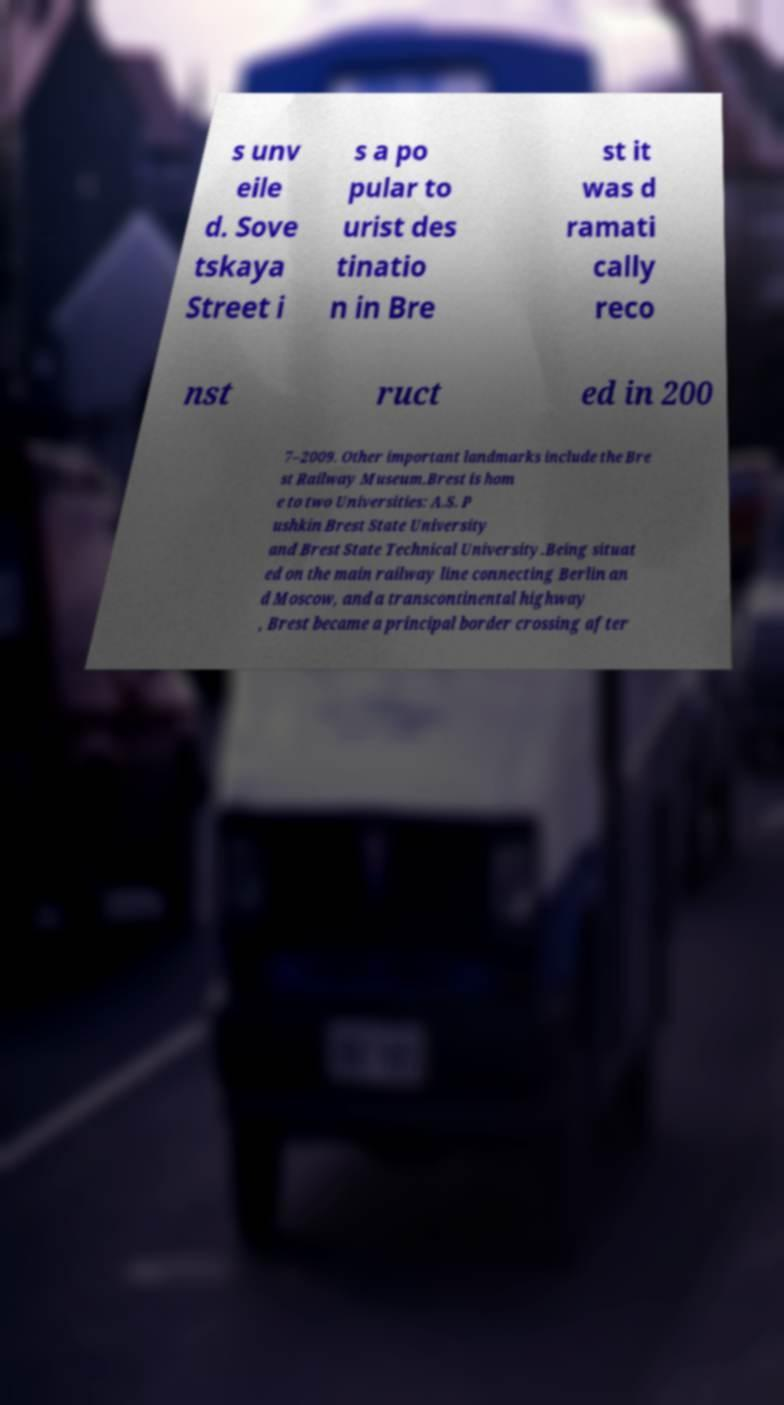Can you accurately transcribe the text from the provided image for me? s unv eile d. Sove tskaya Street i s a po pular to urist des tinatio n in Bre st it was d ramati cally reco nst ruct ed in 200 7–2009. Other important landmarks include the Bre st Railway Museum.Brest is hom e to two Universities: A.S. P ushkin Brest State University and Brest State Technical University.Being situat ed on the main railway line connecting Berlin an d Moscow, and a transcontinental highway , Brest became a principal border crossing after 